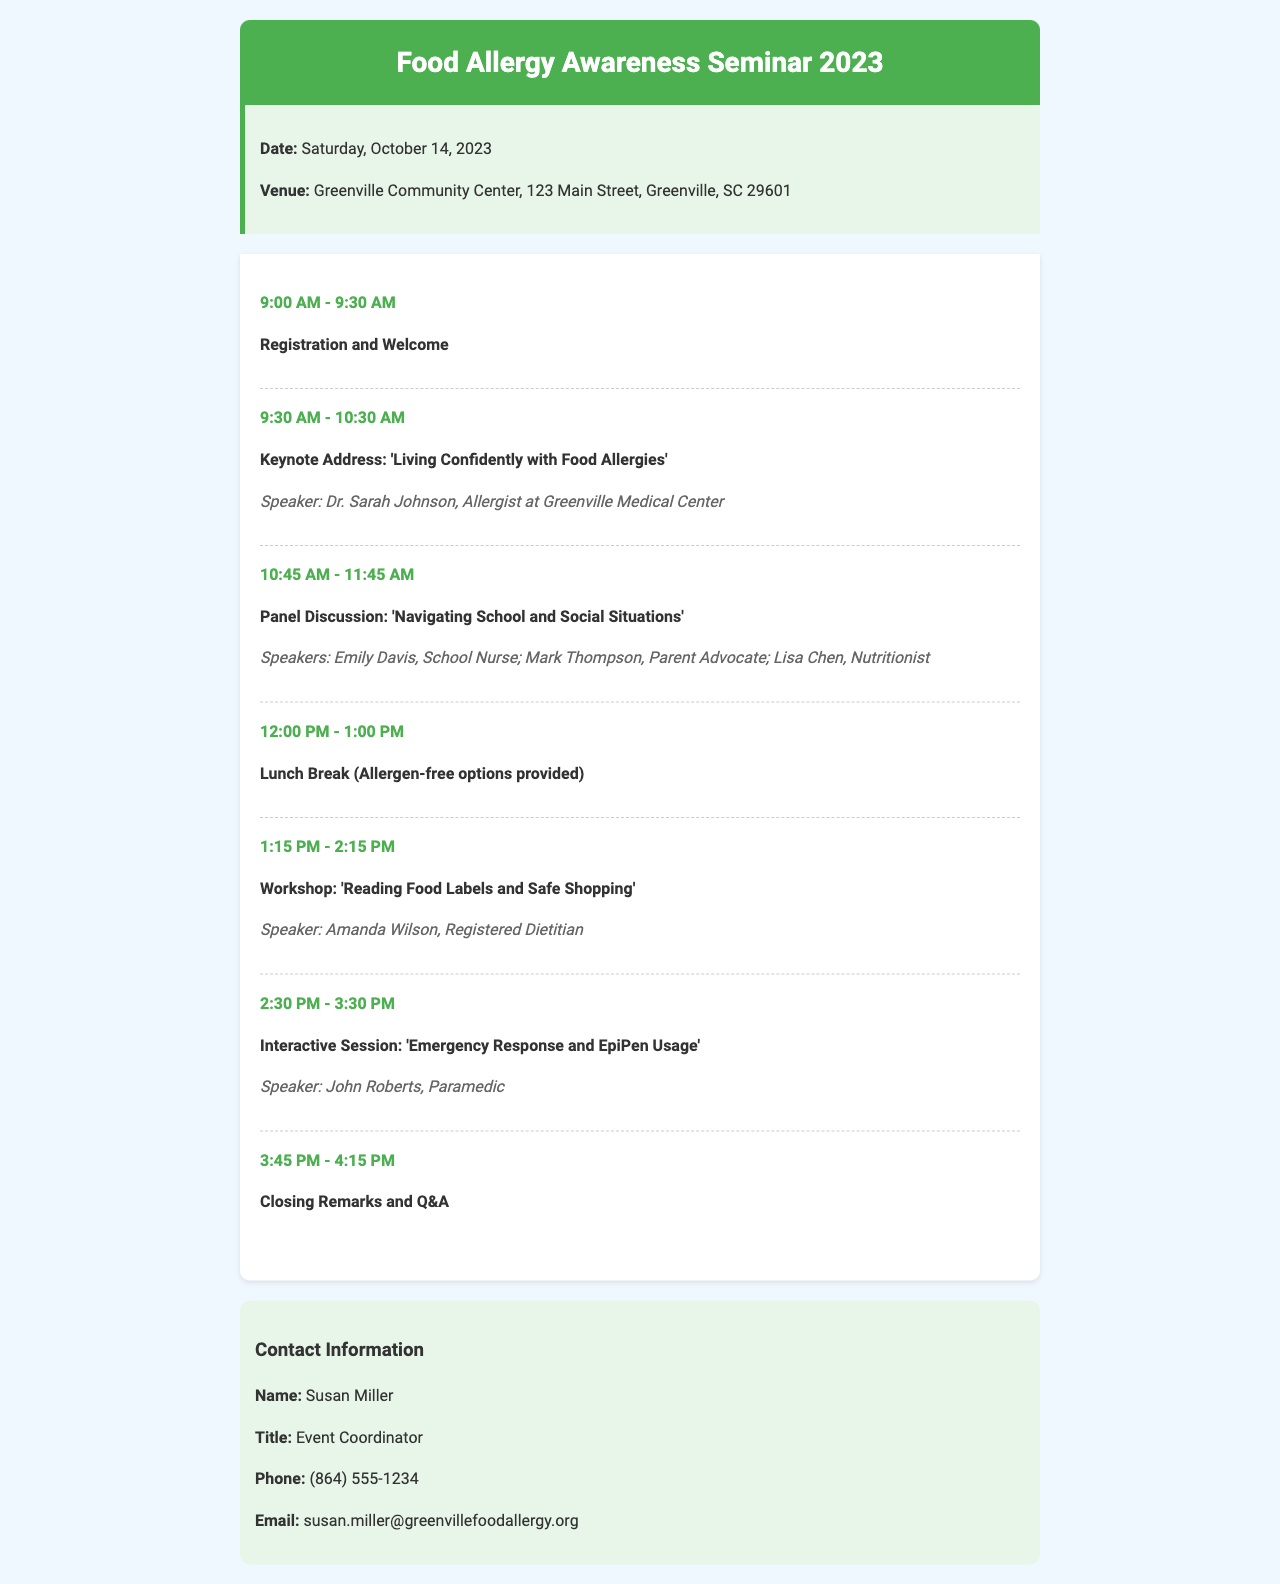What is the date of the seminar? The date of the seminar is mentioned in the event details section.
Answer: Saturday, October 14, 2023 Where is the seminar being held? The venue for the seminar is specified in the event details section.
Answer: Greenville Community Center, 123 Main Street, Greenville, SC 29601 Who is the keynote speaker? The speaker information for the keynote address is provided under the schedule section.
Answer: Dr. Sarah Johnson What time does the registration start? The schedule indicates the time for registration and welcome.
Answer: 9:00 AM How long is the lunch break? The duration of the lunch break is mentioned in the schedule section.
Answer: 1 hour What is the activity after the lunch break? The schedule outlines the next activity following the lunch break.
Answer: Workshop: 'Reading Food Labels and Safe Shopping' Who should be contacted for more information? The contact information section specifies the event coordinator's name.
Answer: Susan Miller What is the phone number for the event coordinator? The phone number is listed in the contact information section of the document.
Answer: (864) 555-1234 What time does the closing remarks start? The schedule indicates when the closing remarks and Q&A will take place.
Answer: 3:45 PM 